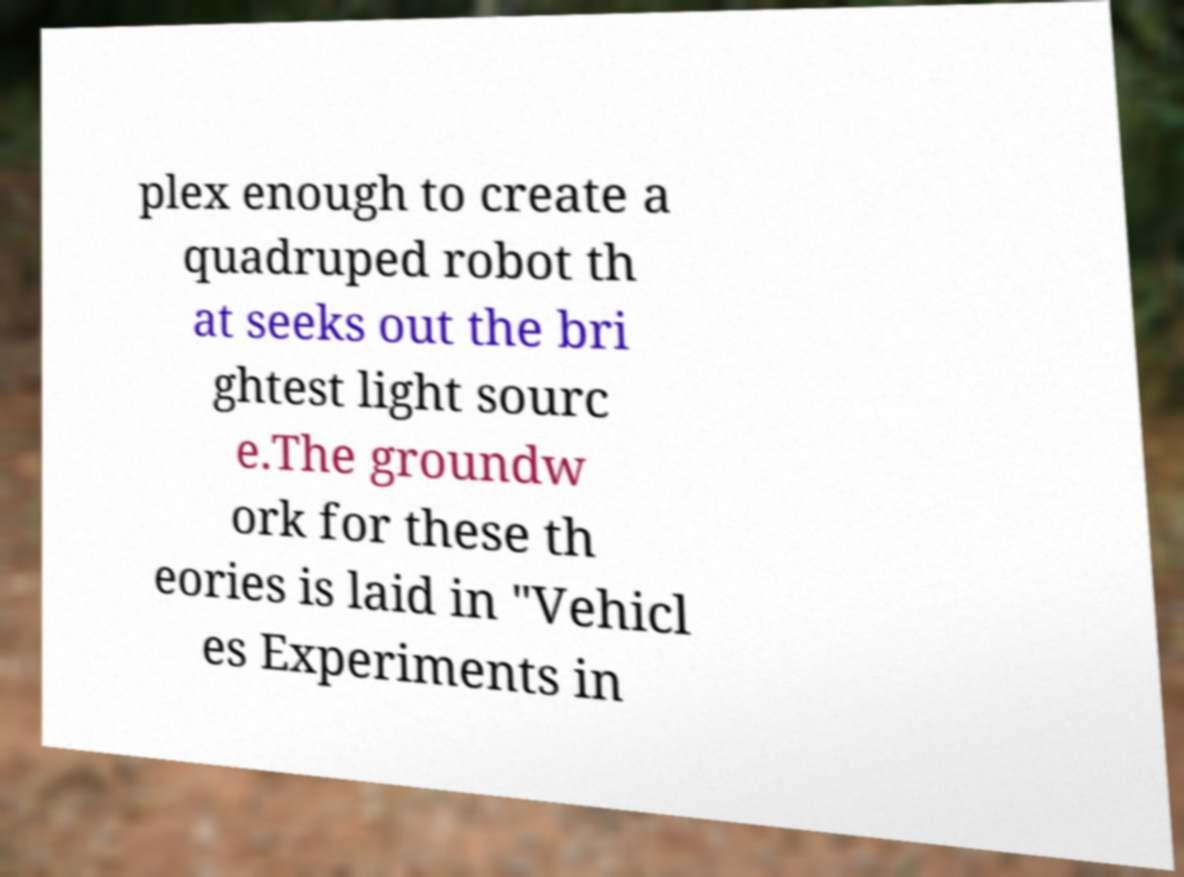Could you assist in decoding the text presented in this image and type it out clearly? plex enough to create a quadruped robot th at seeks out the bri ghtest light sourc e.The groundw ork for these th eories is laid in "Vehicl es Experiments in 